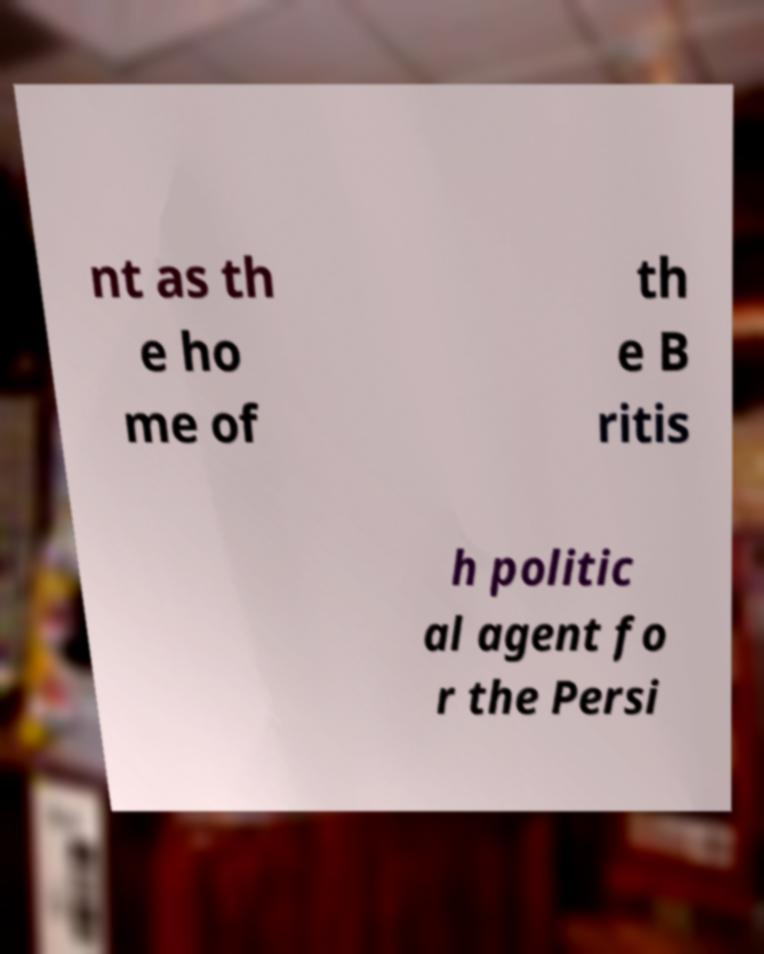Please read and relay the text visible in this image. What does it say? nt as th e ho me of th e B ritis h politic al agent fo r the Persi 